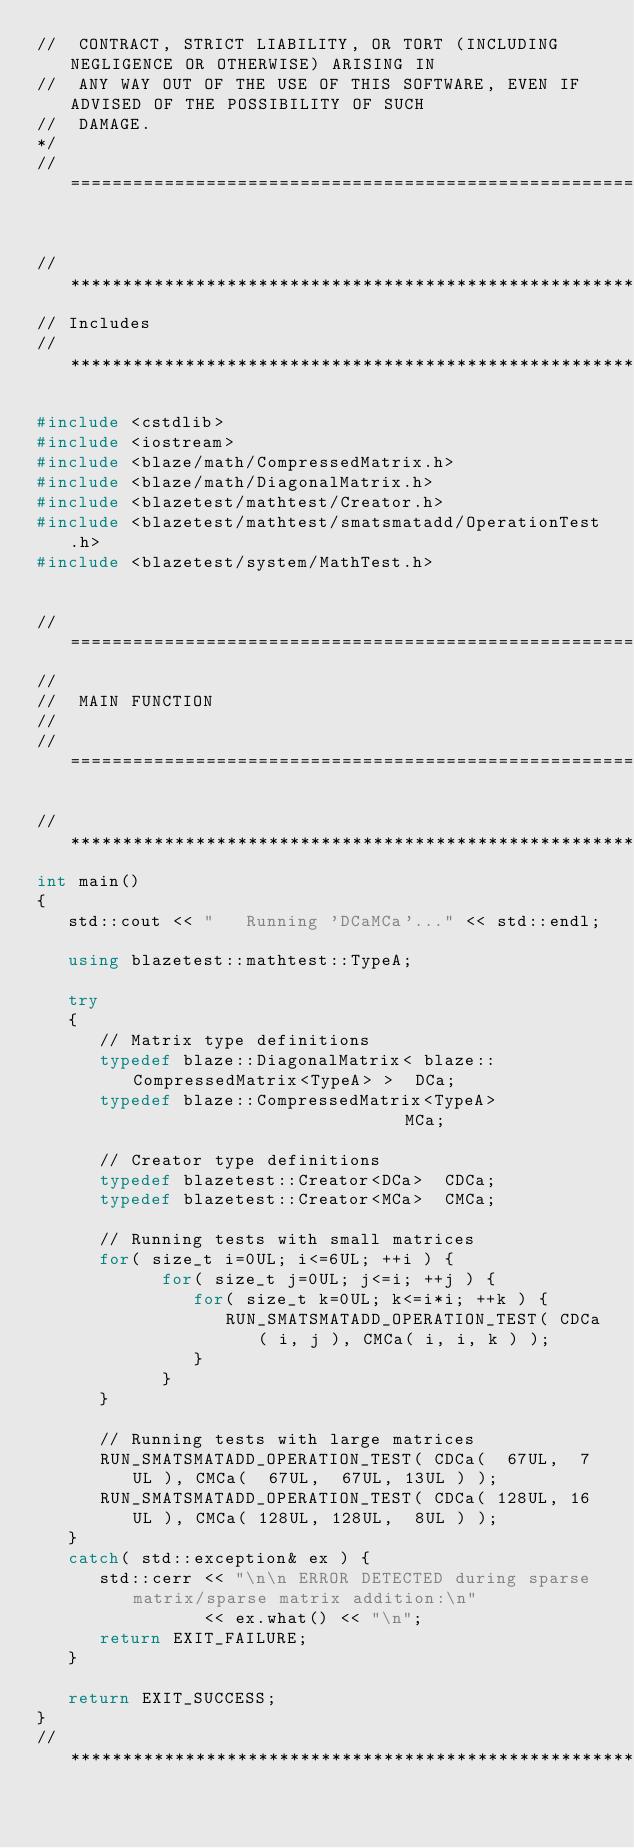<code> <loc_0><loc_0><loc_500><loc_500><_C++_>//  CONTRACT, STRICT LIABILITY, OR TORT (INCLUDING NEGLIGENCE OR OTHERWISE) ARISING IN
//  ANY WAY OUT OF THE USE OF THIS SOFTWARE, EVEN IF ADVISED OF THE POSSIBILITY OF SUCH
//  DAMAGE.
*/
//=================================================================================================


//*************************************************************************************************
// Includes
//*************************************************************************************************

#include <cstdlib>
#include <iostream>
#include <blaze/math/CompressedMatrix.h>
#include <blaze/math/DiagonalMatrix.h>
#include <blazetest/mathtest/Creator.h>
#include <blazetest/mathtest/smatsmatadd/OperationTest.h>
#include <blazetest/system/MathTest.h>


//=================================================================================================
//
//  MAIN FUNCTION
//
//=================================================================================================

//*************************************************************************************************
int main()
{
   std::cout << "   Running 'DCaMCa'..." << std::endl;

   using blazetest::mathtest::TypeA;

   try
   {
      // Matrix type definitions
      typedef blaze::DiagonalMatrix< blaze::CompressedMatrix<TypeA> >  DCa;
      typedef blaze::CompressedMatrix<TypeA>                           MCa;

      // Creator type definitions
      typedef blazetest::Creator<DCa>  CDCa;
      typedef blazetest::Creator<MCa>  CMCa;

      // Running tests with small matrices
      for( size_t i=0UL; i<=6UL; ++i ) {
            for( size_t j=0UL; j<=i; ++j ) {
               for( size_t k=0UL; k<=i*i; ++k ) {
                  RUN_SMATSMATADD_OPERATION_TEST( CDCa( i, j ), CMCa( i, i, k ) );
               }
            }
      }

      // Running tests with large matrices
      RUN_SMATSMATADD_OPERATION_TEST( CDCa(  67UL,  7UL ), CMCa(  67UL,  67UL, 13UL ) );
      RUN_SMATSMATADD_OPERATION_TEST( CDCa( 128UL, 16UL ), CMCa( 128UL, 128UL,  8UL ) );
   }
   catch( std::exception& ex ) {
      std::cerr << "\n\n ERROR DETECTED during sparse matrix/sparse matrix addition:\n"
                << ex.what() << "\n";
      return EXIT_FAILURE;
   }

   return EXIT_SUCCESS;
}
//*************************************************************************************************
</code> 